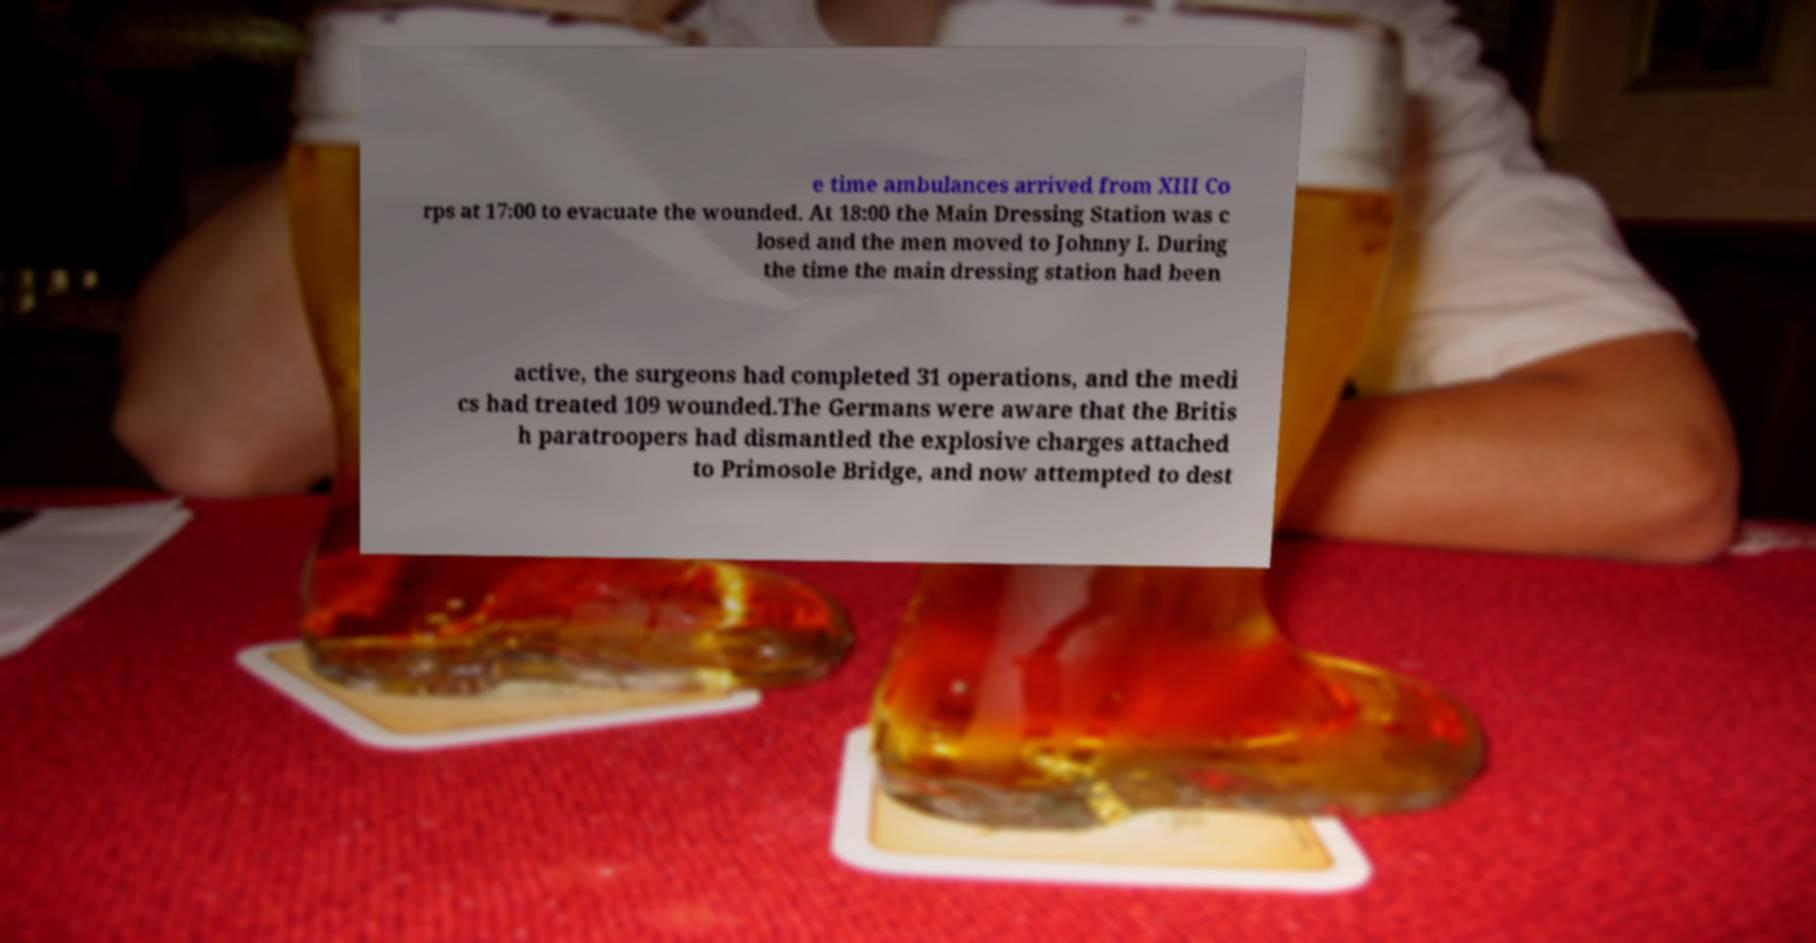There's text embedded in this image that I need extracted. Can you transcribe it verbatim? e time ambulances arrived from XIII Co rps at 17:00 to evacuate the wounded. At 18:00 the Main Dressing Station was c losed and the men moved to Johnny I. During the time the main dressing station had been active, the surgeons had completed 31 operations, and the medi cs had treated 109 wounded.The Germans were aware that the Britis h paratroopers had dismantled the explosive charges attached to Primosole Bridge, and now attempted to dest 